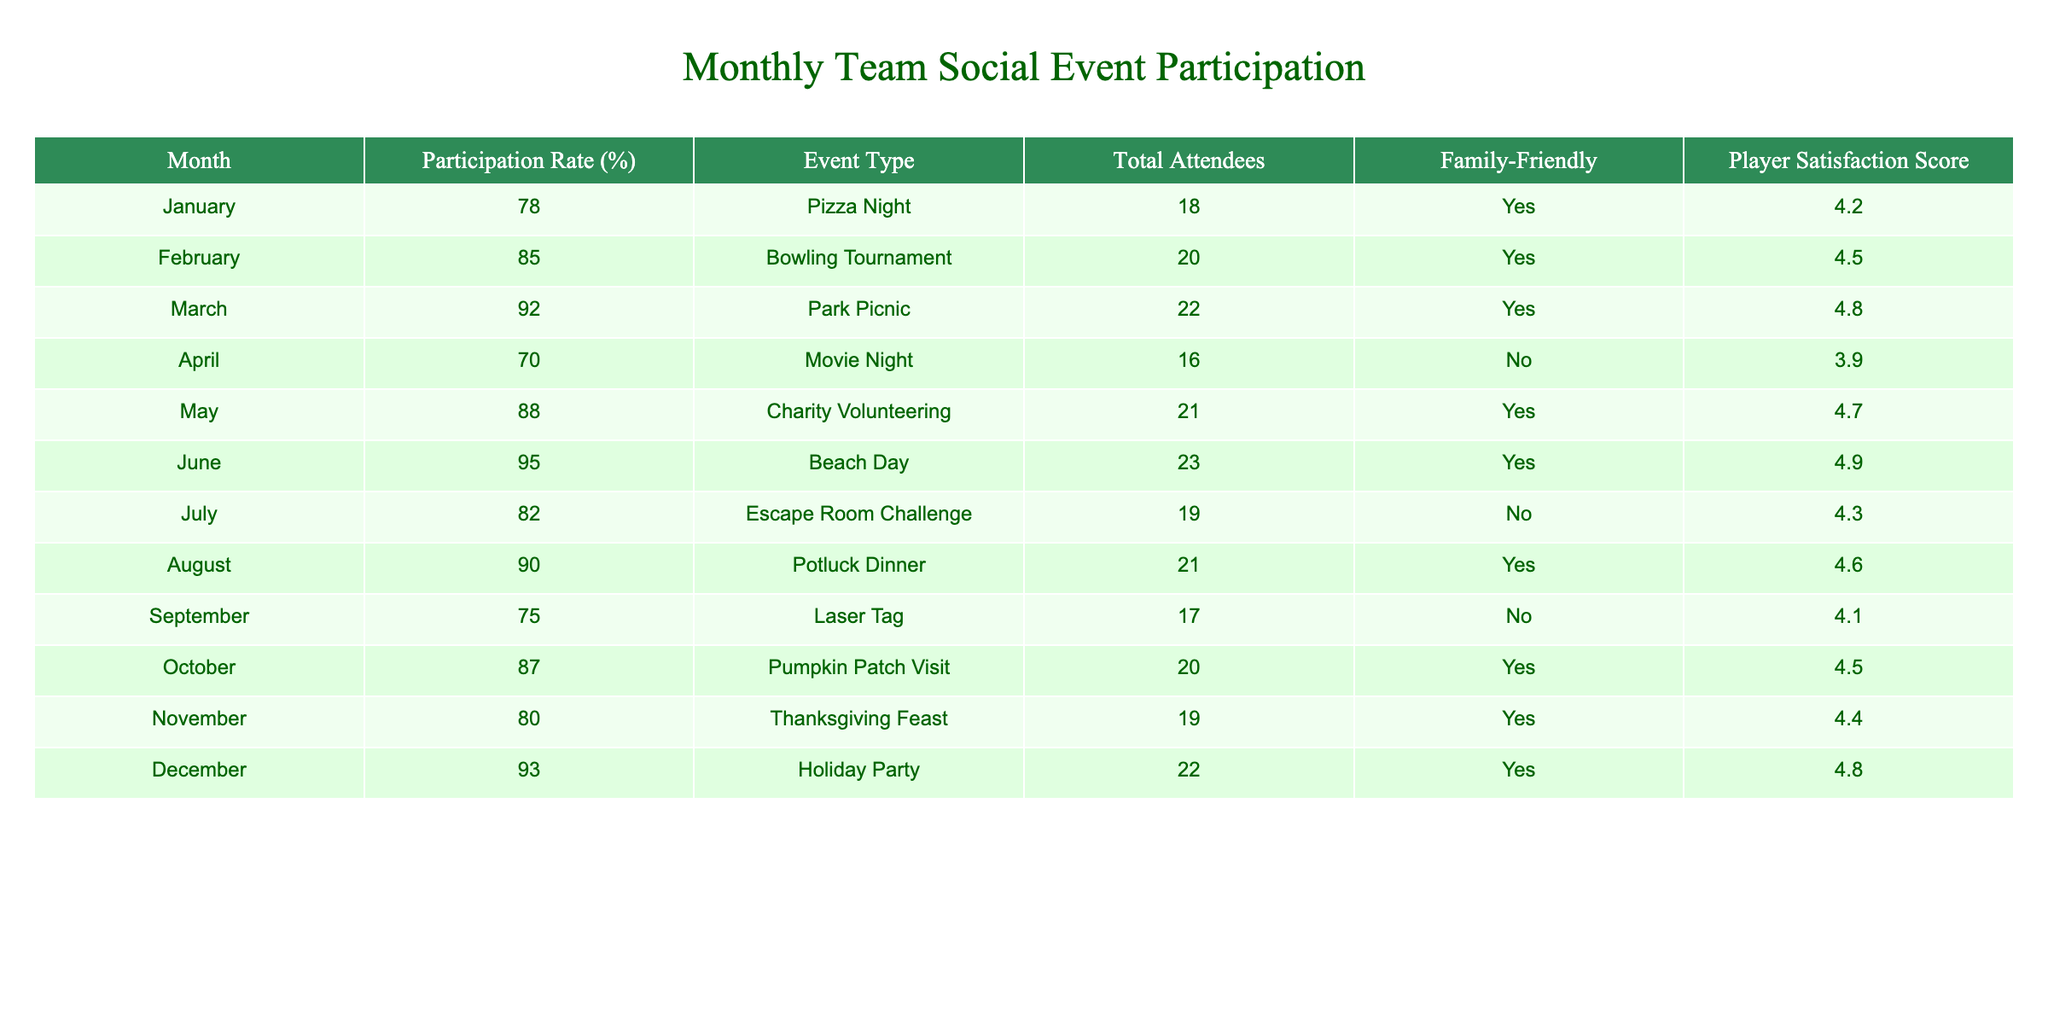What was the participation rate for the Beach Day event? The table shows that the participation rate for the Beach Day event in June was 95%.
Answer: 95% Which event had the lowest player satisfaction score? According to the table, the Movie Night in April had the lowest player satisfaction score of 3.9.
Answer: 3.9 What is the total number of attendees for the Charity Volunteering event? From the table, the Charity Volunteering event in May had a total of 21 attendees.
Answer: 21 Was the Pumpkin Patch Visit a family-friendly event? The table indicates that the Pumpkin Patch Visit in October was family-friendly, marked as "Yes".
Answer: Yes What is the average participation rate for the family-friendly events? The family-friendly events are Pizza Night, Bowling Tournament, Park Picnic, Charity Volunteering, Beach Day, Potluck Dinner, Pumpkin Patch Visit, Thanksgiving Feast, and Holiday Party. Their participation rates are 78, 85, 92, 88, 95, 90, 87, 80, and 93 respectively. The average can be calculated as (78 + 85 + 92 + 88 + 95 + 90 + 87 + 80 + 93) / 9 = 88.67.
Answer: 88.67 Which month had the highest player satisfaction score and what was the score? The highest player satisfaction score in the table is for the Beach Day event in June with a score of 4.9.
Answer: 4.9 How many events had a participation rate lower than 80%? Checking the table, the events with participation rates lower than 80% are Movie Night (70%), Laser Tag (75%), and Thanksgiving Feast (80%). In total, there are 3 events with participation rates lower than 80%.
Answer: 3 Compare the participation rates of events in July and August. Which month had a higher rate? In the table, July's participation rate for the Escape Room Challenge is 82% and August's rate for the Potluck Dinner is 90%. Since 90% is greater than 82%, August had a higher participation rate.
Answer: August What is the difference in the total attendees between the highest and the lowest attended events? The highest attended event is the Beach Day with 23 attendees and the lowest is Laser Tag with 17 attendees. Therefore, the difference is 23 - 17 = 6 attendees.
Answer: 6 Was there any month where players were not satisfied with the event? The table shows that the Movie Night in April had the lowest satisfaction score of 3.9, which indicates low satisfaction.
Answer: Yes How many more attendees did the Park Picnic have compared to the Laser Tag event? The Park Picnic had 22 attendees and the Laser Tag event had 17 attendees. The difference in attendees is 22 - 17 = 5.
Answer: 5 